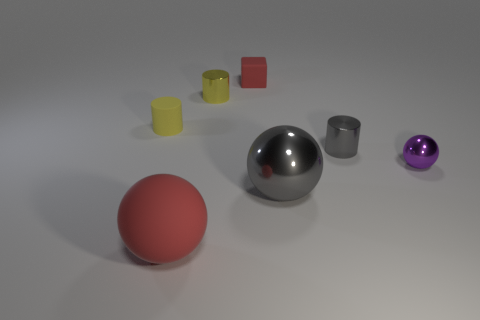What is the material of the red object behind the small yellow matte cylinder that is left of the large ball that is behind the red matte sphere?
Make the answer very short. Rubber. Are there an equal number of tiny gray shiny cylinders that are left of the big gray sphere and small purple rubber objects?
Make the answer very short. Yes. Is the cylinder behind the yellow rubber object made of the same material as the object that is to the left of the large matte object?
Provide a succinct answer. No. How many things are small purple metal spheres or small metal cylinders that are to the left of the gray metal ball?
Your answer should be compact. 2. Are there any matte things of the same shape as the yellow metal object?
Make the answer very short. Yes. There is a red matte thing that is behind the cylinder that is right of the red object that is behind the large metal sphere; what size is it?
Keep it short and to the point. Small. Is the number of small spheres that are behind the tiny yellow rubber cylinder the same as the number of gray cylinders that are to the left of the tiny yellow metal cylinder?
Ensure brevity in your answer.  Yes. There is a cylinder that is the same material as the tiny red thing; what is its size?
Give a very brief answer. Small. The big matte object has what color?
Your response must be concise. Red. How many tiny matte blocks have the same color as the big matte sphere?
Ensure brevity in your answer.  1. 